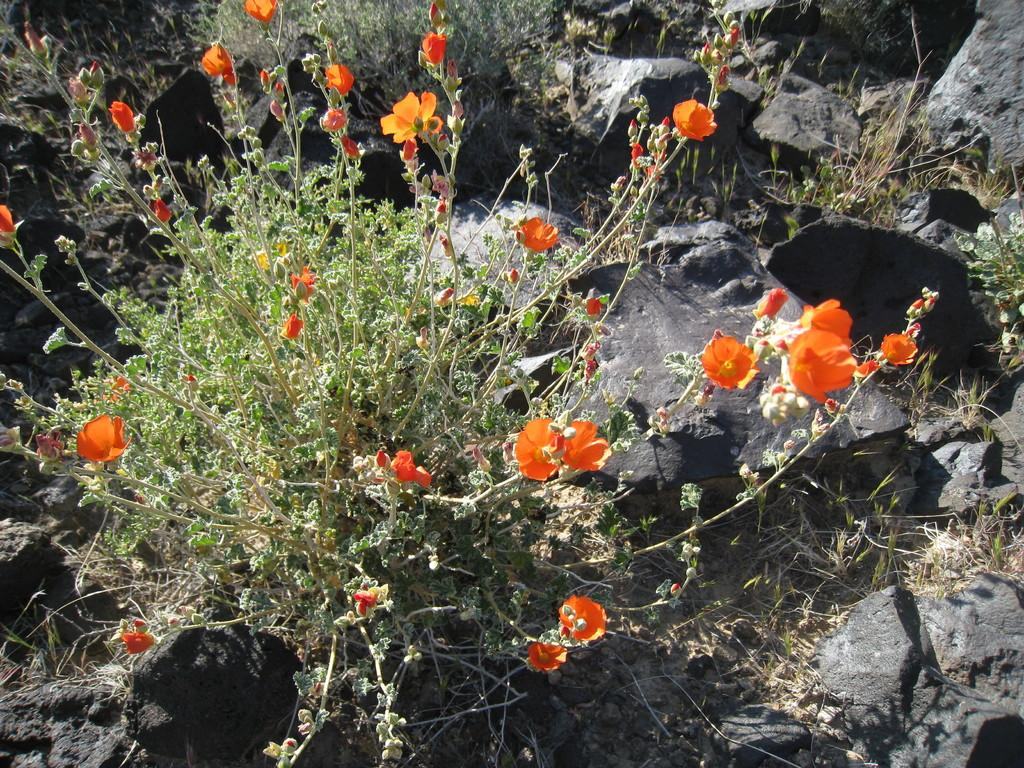What type of plant is in the image? The plant in the image has orange color flowers and green color leaves. What is the color of the flowers on the plant? The flowers on the plant are orange in color. What is the color of the leaves on the plant? The leaves on the plant are green in color. Where is the plant located in the image? The plant is on the ground. What else can be seen on the ground in the image? There are rocks and other plants on the ground. How much hair does the stranger have in the image? There is no stranger present in the image, so it is not possible to determine the amount of hair they might have. 